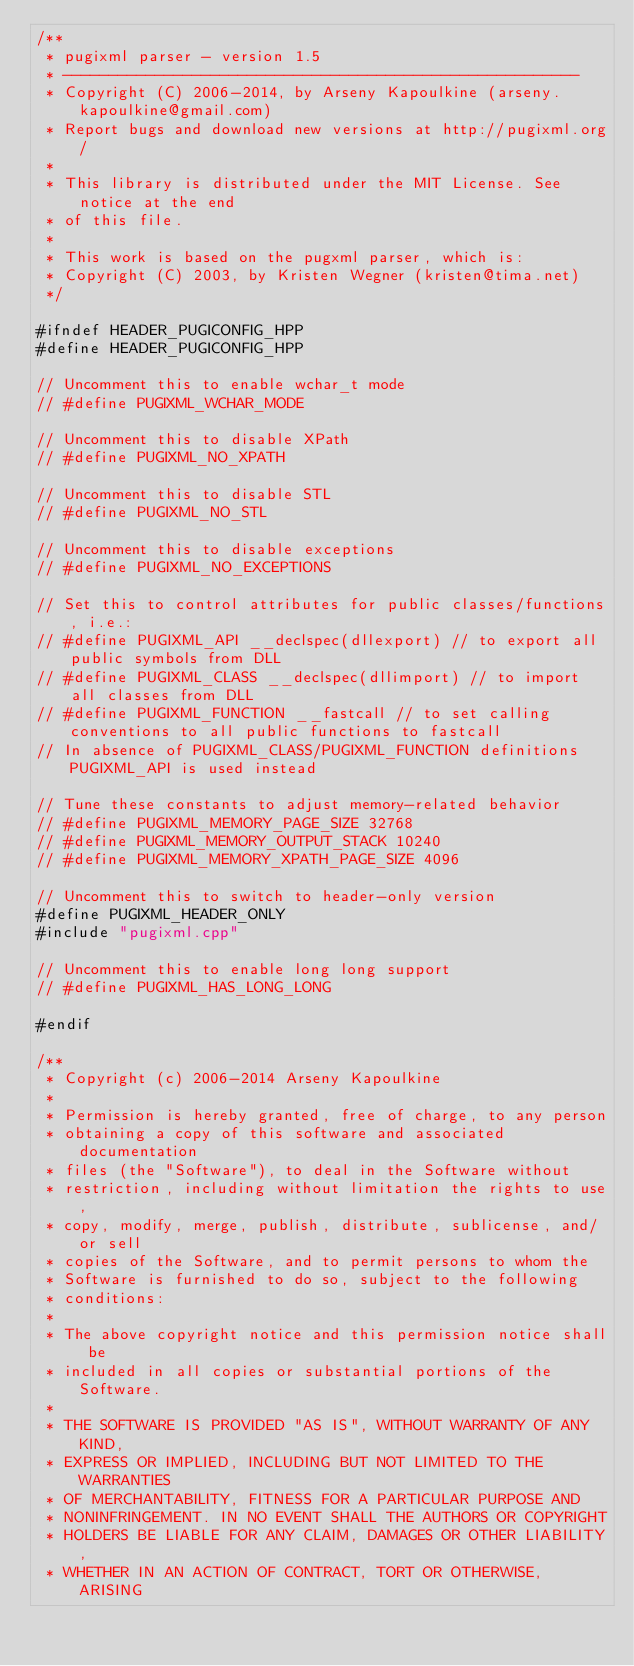<code> <loc_0><loc_0><loc_500><loc_500><_C++_>/**
 * pugixml parser - version 1.5
 * --------------------------------------------------------
 * Copyright (C) 2006-2014, by Arseny Kapoulkine (arseny.kapoulkine@gmail.com)
 * Report bugs and download new versions at http://pugixml.org/
 *
 * This library is distributed under the MIT License. See notice at the end
 * of this file.
 *
 * This work is based on the pugxml parser, which is:
 * Copyright (C) 2003, by Kristen Wegner (kristen@tima.net)
 */

#ifndef HEADER_PUGICONFIG_HPP
#define HEADER_PUGICONFIG_HPP

// Uncomment this to enable wchar_t mode
// #define PUGIXML_WCHAR_MODE

// Uncomment this to disable XPath
// #define PUGIXML_NO_XPATH

// Uncomment this to disable STL
// #define PUGIXML_NO_STL

// Uncomment this to disable exceptions
// #define PUGIXML_NO_EXCEPTIONS

// Set this to control attributes for public classes/functions, i.e.:
// #define PUGIXML_API __declspec(dllexport) // to export all public symbols from DLL
// #define PUGIXML_CLASS __declspec(dllimport) // to import all classes from DLL
// #define PUGIXML_FUNCTION __fastcall // to set calling conventions to all public functions to fastcall
// In absence of PUGIXML_CLASS/PUGIXML_FUNCTION definitions PUGIXML_API is used instead

// Tune these constants to adjust memory-related behavior
// #define PUGIXML_MEMORY_PAGE_SIZE 32768
// #define PUGIXML_MEMORY_OUTPUT_STACK 10240
// #define PUGIXML_MEMORY_XPATH_PAGE_SIZE 4096

// Uncomment this to switch to header-only version
#define PUGIXML_HEADER_ONLY
#include "pugixml.cpp"

// Uncomment this to enable long long support
// #define PUGIXML_HAS_LONG_LONG

#endif

/**
 * Copyright (c) 2006-2014 Arseny Kapoulkine
 *
 * Permission is hereby granted, free of charge, to any person
 * obtaining a copy of this software and associated documentation
 * files (the "Software"), to deal in the Software without
 * restriction, including without limitation the rights to use,
 * copy, modify, merge, publish, distribute, sublicense, and/or sell
 * copies of the Software, and to permit persons to whom the
 * Software is furnished to do so, subject to the following
 * conditions:
 *
 * The above copyright notice and this permission notice shall be
 * included in all copies or substantial portions of the Software.
 * 
 * THE SOFTWARE IS PROVIDED "AS IS", WITHOUT WARRANTY OF ANY KIND,
 * EXPRESS OR IMPLIED, INCLUDING BUT NOT LIMITED TO THE WARRANTIES
 * OF MERCHANTABILITY, FITNESS FOR A PARTICULAR PURPOSE AND
 * NONINFRINGEMENT. IN NO EVENT SHALL THE AUTHORS OR COPYRIGHT
 * HOLDERS BE LIABLE FOR ANY CLAIM, DAMAGES OR OTHER LIABILITY,
 * WHETHER IN AN ACTION OF CONTRACT, TORT OR OTHERWISE, ARISING</code> 